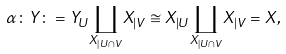<formula> <loc_0><loc_0><loc_500><loc_500>\alpha \colon Y \colon = Y _ { U } \underset { X _ { | U \cap V } } \coprod X _ { | V } \cong X _ { | U } \underset { X _ { | U \cap V } } \coprod X _ { | V } = X ,</formula> 